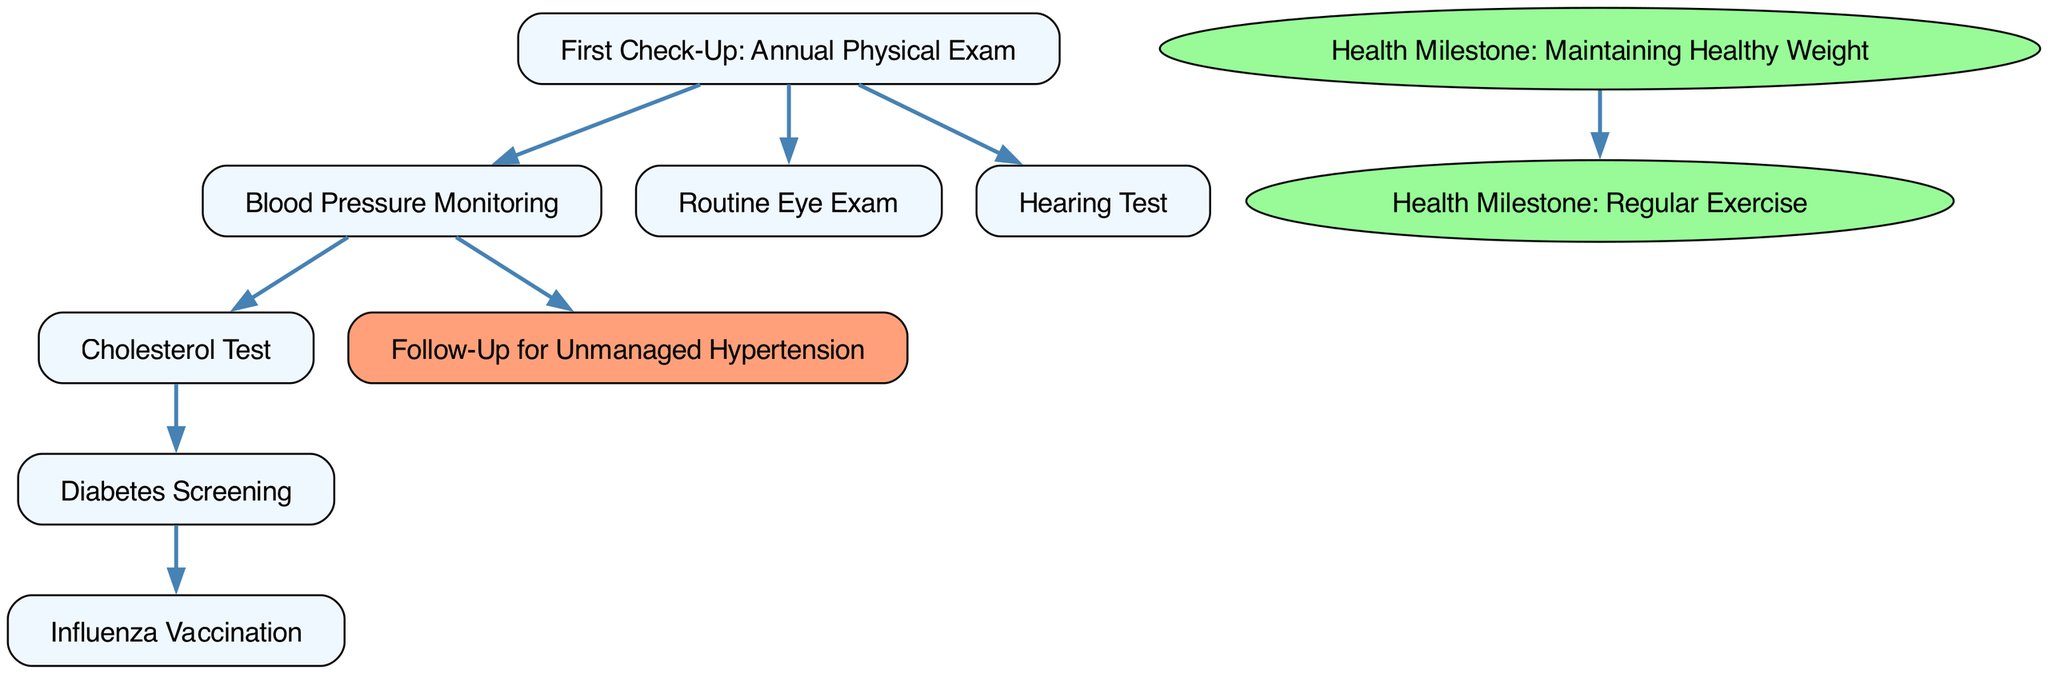What is the label of the first node? The first node in the diagram represents the starting point of the timeline, labeled as "First Check-Up: Annual Physical Exam."
Answer: First Check-Up: Annual Physical Exam How many health milestones are shown in the diagram? There are two health milestones depicted in the diagram, specifically "Health Milestone: Maintaining Healthy Weight" and "Health Milestone: Regular Exercise."
Answer: 2 Which check-up is directly linked to blood pressure monitoring? Blood pressure monitoring is the next step that follows the "First Check-Up: Annual Physical Exam," indicating a direct relationship between those two nodes.
Answer: Blood Pressure Monitoring What type of node is "Follow-Up for Unmanaged Hypertension"? "Follow-Up for Unmanaged Hypertension" is categorized as a follow-up node because it's linked to blood pressure monitoring and colored differently in the diagram.
Answer: Follow-Up What are the two health milestones connected by an edge? The two health milestones connected by an edge are "Health Milestone: Maintaining Healthy Weight" and "Health Milestone: Regular Exercise," indicating progression and relationship between maintaining weight and regular exercise.
Answer: Maintaining Healthy Weight, Regular Exercise What node follows the "Cholesterol Test" in the diagram? The "Cholesterol Test" node is connected directly to the "Diabetes Screening" node, making it the subsequent check-up after cholesterol testing.
Answer: Diabetes Screening Which node has the most incoming edges in the diagram? The "Follow-Up for Unmanaged Hypertension" node has one incoming edge from "Blood Pressure Monitoring," making it the only node with a direct follow-up context from a previous node.
Answer: Follow-Up for Unmanaged Hypertension What color is used for health milestone nodes? The health milestone nodes are depicted in an ellipse shape filled with a light green color (#98FB98), distinguishing them visually from other types of nodes.
Answer: Light green How many nodes lead to the "Diabetes Screening" node? One node leads to the "Diabetes Screening," specifically the "Cholesterol Test," which is the only node that connects directly to it.
Answer: 1 